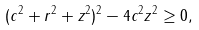Convert formula to latex. <formula><loc_0><loc_0><loc_500><loc_500>( c ^ { 2 } + r ^ { 2 } + z ^ { 2 } ) ^ { 2 } - 4 c ^ { 2 } z ^ { 2 } \geq 0 ,</formula> 